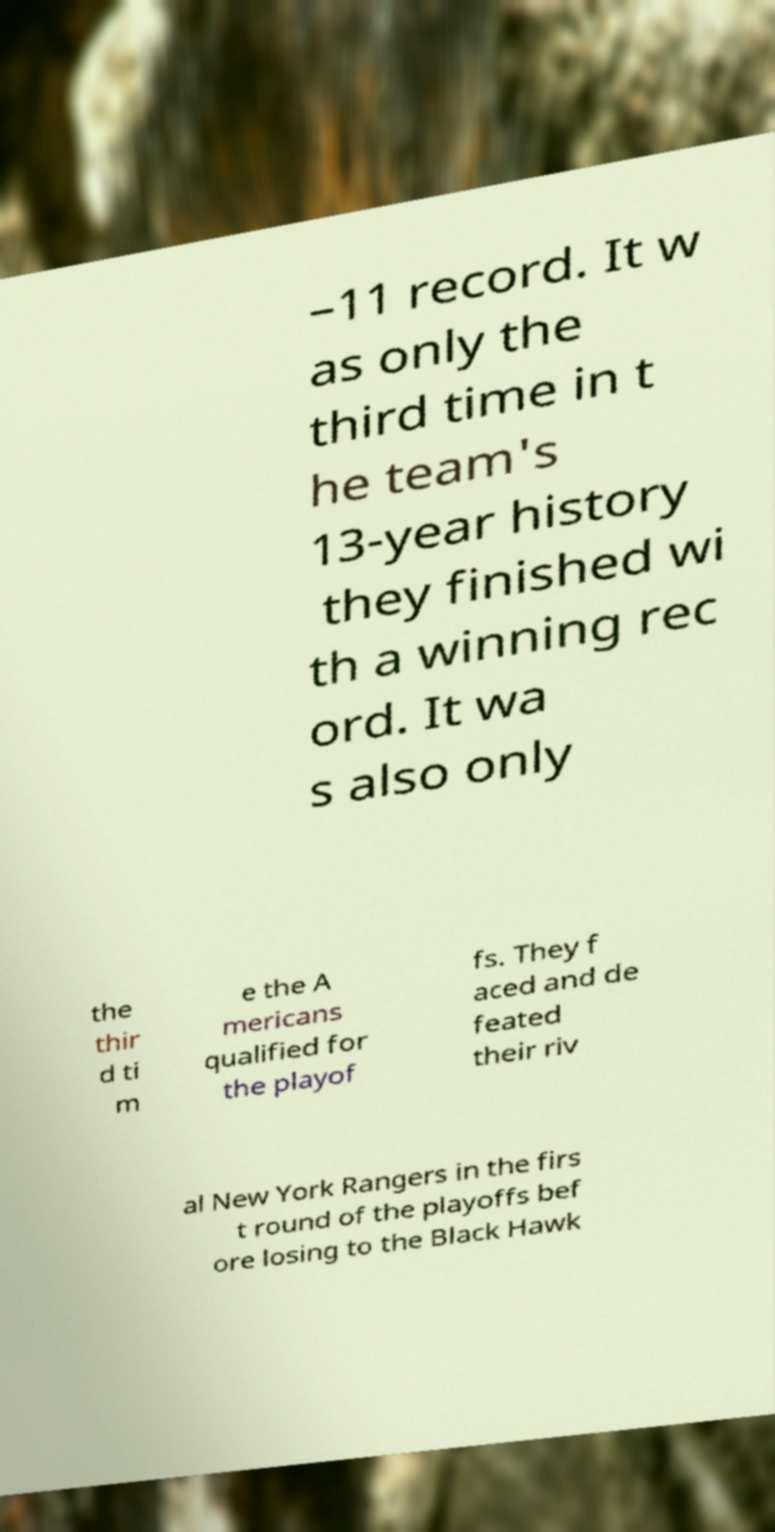Could you extract and type out the text from this image? –11 record. It w as only the third time in t he team's 13-year history they finished wi th a winning rec ord. It wa s also only the thir d ti m e the A mericans qualified for the playof fs. They f aced and de feated their riv al New York Rangers in the firs t round of the playoffs bef ore losing to the Black Hawk 